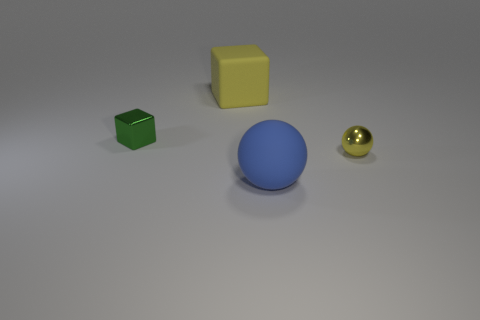How many green things are big rubber blocks or large things?
Offer a terse response. 0. Are there any metal cylinders that have the same color as the big block?
Provide a short and direct response. No. What size is the object that is made of the same material as the big yellow block?
Give a very brief answer. Large. What number of cubes are either large blue things or tiny objects?
Offer a terse response. 1. Is the number of tiny green things greater than the number of brown cubes?
Give a very brief answer. Yes. What number of other metallic blocks are the same size as the green metal block?
Your response must be concise. 0. What is the shape of the big thing that is the same color as the shiny sphere?
Your response must be concise. Cube. How many objects are either small objects on the right side of the small green object or large gray shiny cubes?
Ensure brevity in your answer.  1. Are there fewer large yellow objects than small purple metallic blocks?
Offer a terse response. No. What shape is the small green thing that is the same material as the small sphere?
Keep it short and to the point. Cube. 